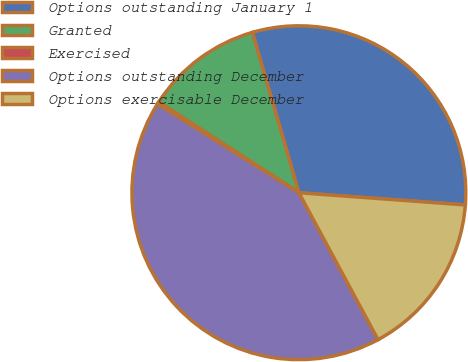<chart> <loc_0><loc_0><loc_500><loc_500><pie_chart><fcel>Options outstanding January 1<fcel>Granted<fcel>Exercised<fcel>Options outstanding December<fcel>Options exercisable December<nl><fcel>30.66%<fcel>11.36%<fcel>0.22%<fcel>41.8%<fcel>15.97%<nl></chart> 